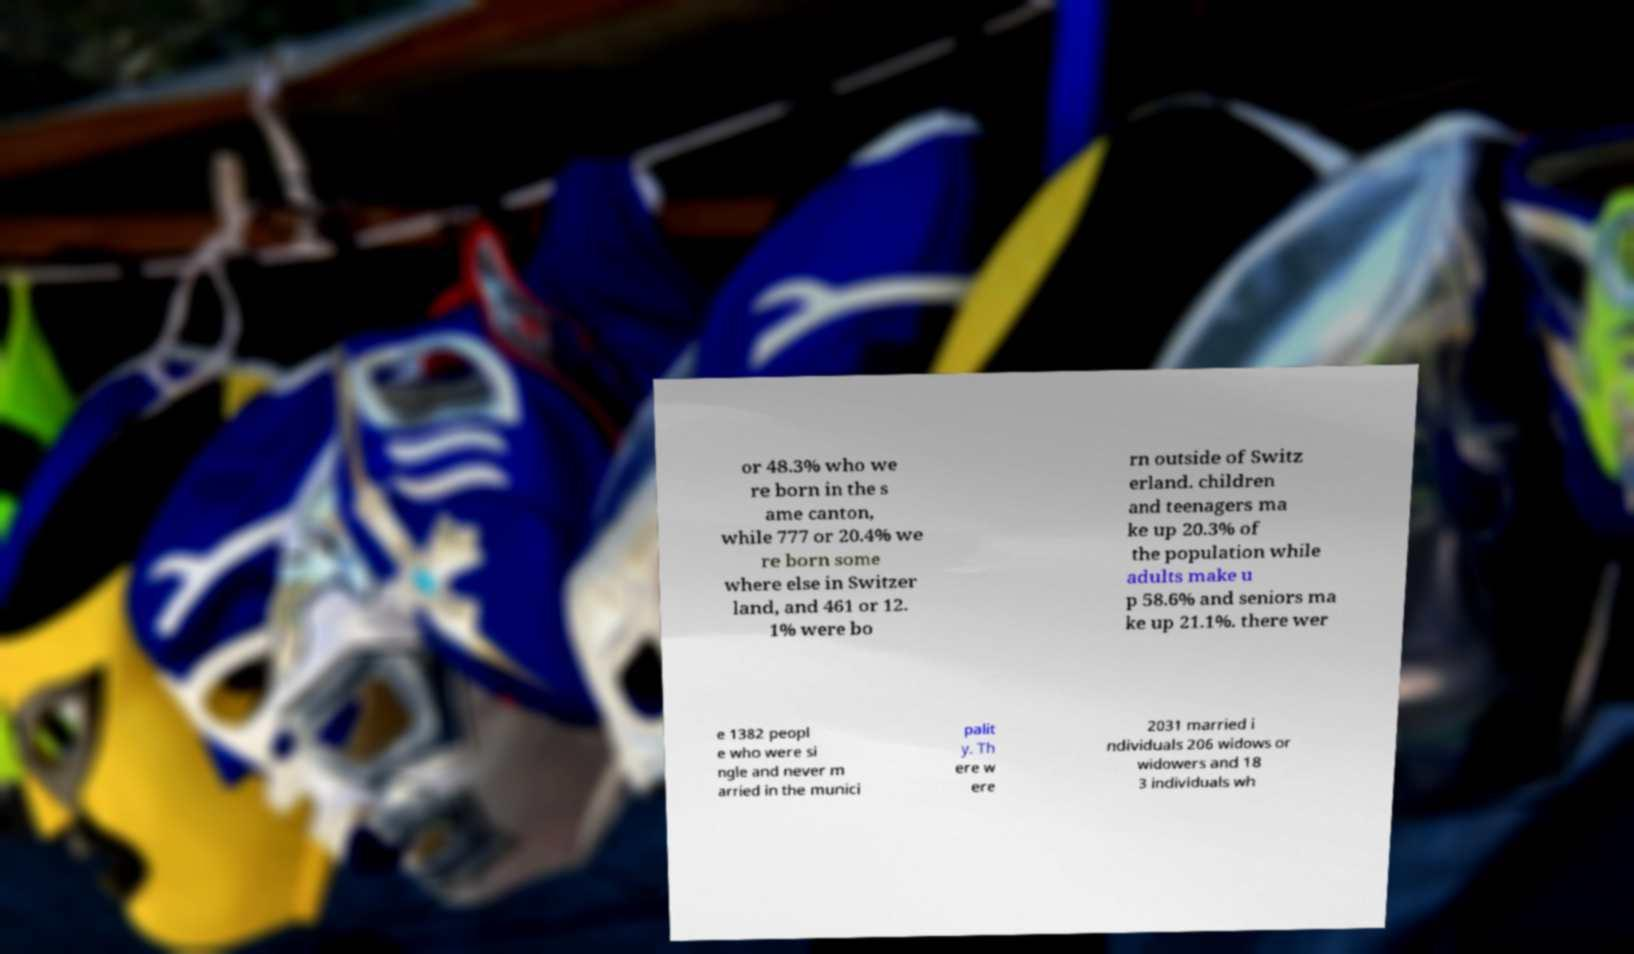I need the written content from this picture converted into text. Can you do that? or 48.3% who we re born in the s ame canton, while 777 or 20.4% we re born some where else in Switzer land, and 461 or 12. 1% were bo rn outside of Switz erland. children and teenagers ma ke up 20.3% of the population while adults make u p 58.6% and seniors ma ke up 21.1%. there wer e 1382 peopl e who were si ngle and never m arried in the munici palit y. Th ere w ere 2031 married i ndividuals 206 widows or widowers and 18 3 individuals wh 